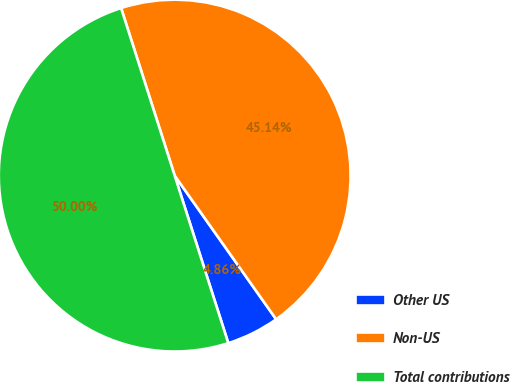Convert chart to OTSL. <chart><loc_0><loc_0><loc_500><loc_500><pie_chart><fcel>Other US<fcel>Non-US<fcel>Total contributions<nl><fcel>4.86%<fcel>45.14%<fcel>50.0%<nl></chart> 